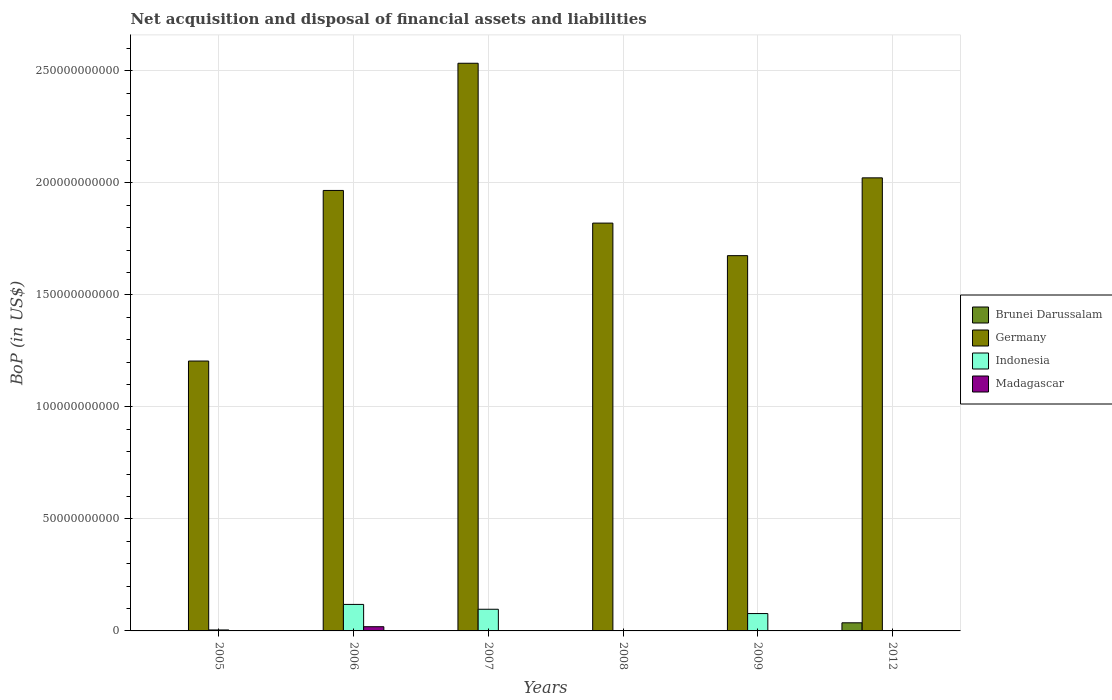How many different coloured bars are there?
Make the answer very short. 4. What is the Balance of Payments in Madagascar in 2008?
Ensure brevity in your answer.  0. Across all years, what is the maximum Balance of Payments in Indonesia?
Offer a terse response. 1.18e+1. Across all years, what is the minimum Balance of Payments in Germany?
Your answer should be very brief. 1.20e+11. What is the total Balance of Payments in Indonesia in the graph?
Provide a short and direct response. 2.99e+1. What is the difference between the Balance of Payments in Indonesia in 2006 and that in 2009?
Keep it short and to the point. 4.09e+09. What is the difference between the Balance of Payments in Brunei Darussalam in 2007 and the Balance of Payments in Germany in 2009?
Offer a terse response. -1.68e+11. What is the average Balance of Payments in Madagascar per year?
Make the answer very short. 3.13e+08. In the year 2012, what is the difference between the Balance of Payments in Brunei Darussalam and Balance of Payments in Germany?
Ensure brevity in your answer.  -1.99e+11. In how many years, is the Balance of Payments in Germany greater than 100000000000 US$?
Offer a very short reply. 6. What is the ratio of the Balance of Payments in Germany in 2006 to that in 2007?
Your response must be concise. 0.78. What is the difference between the highest and the second highest Balance of Payments in Indonesia?
Keep it short and to the point. 2.16e+09. What is the difference between the highest and the lowest Balance of Payments in Germany?
Give a very brief answer. 1.33e+11. In how many years, is the Balance of Payments in Madagascar greater than the average Balance of Payments in Madagascar taken over all years?
Provide a succinct answer. 1. Is the sum of the Balance of Payments in Germany in 2009 and 2012 greater than the maximum Balance of Payments in Indonesia across all years?
Give a very brief answer. Yes. Is it the case that in every year, the sum of the Balance of Payments in Brunei Darussalam and Balance of Payments in Germany is greater than the sum of Balance of Payments in Indonesia and Balance of Payments in Madagascar?
Your answer should be compact. No. Is it the case that in every year, the sum of the Balance of Payments in Madagascar and Balance of Payments in Brunei Darussalam is greater than the Balance of Payments in Indonesia?
Your answer should be very brief. No. How many years are there in the graph?
Make the answer very short. 6. Are the values on the major ticks of Y-axis written in scientific E-notation?
Your answer should be compact. No. Does the graph contain any zero values?
Provide a succinct answer. Yes. Where does the legend appear in the graph?
Offer a terse response. Center right. How many legend labels are there?
Keep it short and to the point. 4. How are the legend labels stacked?
Ensure brevity in your answer.  Vertical. What is the title of the graph?
Your response must be concise. Net acquisition and disposal of financial assets and liabilities. Does "Bosnia and Herzegovina" appear as one of the legend labels in the graph?
Keep it short and to the point. No. What is the label or title of the X-axis?
Provide a short and direct response. Years. What is the label or title of the Y-axis?
Your answer should be compact. BoP (in US$). What is the BoP (in US$) of Brunei Darussalam in 2005?
Your answer should be compact. 5.58e+07. What is the BoP (in US$) of Germany in 2005?
Your answer should be very brief. 1.20e+11. What is the BoP (in US$) of Indonesia in 2005?
Keep it short and to the point. 4.33e+08. What is the BoP (in US$) in Germany in 2006?
Provide a short and direct response. 1.97e+11. What is the BoP (in US$) in Indonesia in 2006?
Give a very brief answer. 1.18e+1. What is the BoP (in US$) of Madagascar in 2006?
Your answer should be very brief. 1.88e+09. What is the BoP (in US$) in Germany in 2007?
Your answer should be very brief. 2.53e+11. What is the BoP (in US$) in Indonesia in 2007?
Your answer should be very brief. 9.67e+09. What is the BoP (in US$) of Brunei Darussalam in 2008?
Provide a short and direct response. 0. What is the BoP (in US$) of Germany in 2008?
Your answer should be very brief. 1.82e+11. What is the BoP (in US$) of Indonesia in 2008?
Offer a terse response. 1.82e+08. What is the BoP (in US$) in Madagascar in 2008?
Offer a very short reply. 0. What is the BoP (in US$) in Germany in 2009?
Keep it short and to the point. 1.68e+11. What is the BoP (in US$) in Indonesia in 2009?
Offer a very short reply. 7.75e+09. What is the BoP (in US$) of Brunei Darussalam in 2012?
Keep it short and to the point. 3.62e+09. What is the BoP (in US$) of Germany in 2012?
Make the answer very short. 2.02e+11. What is the BoP (in US$) of Indonesia in 2012?
Your answer should be very brief. 0. What is the BoP (in US$) of Madagascar in 2012?
Give a very brief answer. 0. Across all years, what is the maximum BoP (in US$) of Brunei Darussalam?
Ensure brevity in your answer.  3.62e+09. Across all years, what is the maximum BoP (in US$) of Germany?
Give a very brief answer. 2.53e+11. Across all years, what is the maximum BoP (in US$) in Indonesia?
Provide a succinct answer. 1.18e+1. Across all years, what is the maximum BoP (in US$) of Madagascar?
Ensure brevity in your answer.  1.88e+09. Across all years, what is the minimum BoP (in US$) of Germany?
Your answer should be compact. 1.20e+11. What is the total BoP (in US$) in Brunei Darussalam in the graph?
Provide a succinct answer. 3.68e+09. What is the total BoP (in US$) of Germany in the graph?
Offer a terse response. 1.12e+12. What is the total BoP (in US$) in Indonesia in the graph?
Your response must be concise. 2.99e+1. What is the total BoP (in US$) of Madagascar in the graph?
Make the answer very short. 1.88e+09. What is the difference between the BoP (in US$) in Germany in 2005 and that in 2006?
Your answer should be very brief. -7.62e+1. What is the difference between the BoP (in US$) of Indonesia in 2005 and that in 2006?
Ensure brevity in your answer.  -1.14e+1. What is the difference between the BoP (in US$) in Germany in 2005 and that in 2007?
Give a very brief answer. -1.33e+11. What is the difference between the BoP (in US$) in Indonesia in 2005 and that in 2007?
Offer a very short reply. -9.24e+09. What is the difference between the BoP (in US$) of Germany in 2005 and that in 2008?
Give a very brief answer. -6.16e+1. What is the difference between the BoP (in US$) in Indonesia in 2005 and that in 2008?
Your answer should be compact. 2.51e+08. What is the difference between the BoP (in US$) of Germany in 2005 and that in 2009?
Your answer should be very brief. -4.70e+1. What is the difference between the BoP (in US$) of Indonesia in 2005 and that in 2009?
Your answer should be very brief. -7.32e+09. What is the difference between the BoP (in US$) in Brunei Darussalam in 2005 and that in 2012?
Your answer should be very brief. -3.57e+09. What is the difference between the BoP (in US$) in Germany in 2005 and that in 2012?
Ensure brevity in your answer.  -8.18e+1. What is the difference between the BoP (in US$) in Germany in 2006 and that in 2007?
Offer a very short reply. -5.68e+1. What is the difference between the BoP (in US$) in Indonesia in 2006 and that in 2007?
Make the answer very short. 2.16e+09. What is the difference between the BoP (in US$) in Germany in 2006 and that in 2008?
Provide a succinct answer. 1.46e+1. What is the difference between the BoP (in US$) of Indonesia in 2006 and that in 2008?
Provide a succinct answer. 1.17e+1. What is the difference between the BoP (in US$) of Germany in 2006 and that in 2009?
Keep it short and to the point. 2.91e+1. What is the difference between the BoP (in US$) in Indonesia in 2006 and that in 2009?
Keep it short and to the point. 4.09e+09. What is the difference between the BoP (in US$) of Germany in 2006 and that in 2012?
Provide a succinct answer. -5.62e+09. What is the difference between the BoP (in US$) of Germany in 2007 and that in 2008?
Ensure brevity in your answer.  7.13e+1. What is the difference between the BoP (in US$) of Indonesia in 2007 and that in 2008?
Provide a succinct answer. 9.49e+09. What is the difference between the BoP (in US$) of Germany in 2007 and that in 2009?
Ensure brevity in your answer.  8.59e+1. What is the difference between the BoP (in US$) of Indonesia in 2007 and that in 2009?
Your answer should be compact. 1.92e+09. What is the difference between the BoP (in US$) of Germany in 2007 and that in 2012?
Your answer should be compact. 5.11e+1. What is the difference between the BoP (in US$) in Germany in 2008 and that in 2009?
Ensure brevity in your answer.  1.45e+1. What is the difference between the BoP (in US$) in Indonesia in 2008 and that in 2009?
Ensure brevity in your answer.  -7.57e+09. What is the difference between the BoP (in US$) in Germany in 2008 and that in 2012?
Ensure brevity in your answer.  -2.02e+1. What is the difference between the BoP (in US$) in Germany in 2009 and that in 2012?
Keep it short and to the point. -3.47e+1. What is the difference between the BoP (in US$) in Brunei Darussalam in 2005 and the BoP (in US$) in Germany in 2006?
Give a very brief answer. -1.97e+11. What is the difference between the BoP (in US$) in Brunei Darussalam in 2005 and the BoP (in US$) in Indonesia in 2006?
Give a very brief answer. -1.18e+1. What is the difference between the BoP (in US$) in Brunei Darussalam in 2005 and the BoP (in US$) in Madagascar in 2006?
Your answer should be very brief. -1.82e+09. What is the difference between the BoP (in US$) of Germany in 2005 and the BoP (in US$) of Indonesia in 2006?
Provide a short and direct response. 1.09e+11. What is the difference between the BoP (in US$) in Germany in 2005 and the BoP (in US$) in Madagascar in 2006?
Offer a terse response. 1.19e+11. What is the difference between the BoP (in US$) of Indonesia in 2005 and the BoP (in US$) of Madagascar in 2006?
Your answer should be compact. -1.45e+09. What is the difference between the BoP (in US$) in Brunei Darussalam in 2005 and the BoP (in US$) in Germany in 2007?
Make the answer very short. -2.53e+11. What is the difference between the BoP (in US$) of Brunei Darussalam in 2005 and the BoP (in US$) of Indonesia in 2007?
Your response must be concise. -9.61e+09. What is the difference between the BoP (in US$) of Germany in 2005 and the BoP (in US$) of Indonesia in 2007?
Provide a short and direct response. 1.11e+11. What is the difference between the BoP (in US$) in Brunei Darussalam in 2005 and the BoP (in US$) in Germany in 2008?
Provide a short and direct response. -1.82e+11. What is the difference between the BoP (in US$) in Brunei Darussalam in 2005 and the BoP (in US$) in Indonesia in 2008?
Provide a succinct answer. -1.26e+08. What is the difference between the BoP (in US$) of Germany in 2005 and the BoP (in US$) of Indonesia in 2008?
Offer a terse response. 1.20e+11. What is the difference between the BoP (in US$) in Brunei Darussalam in 2005 and the BoP (in US$) in Germany in 2009?
Offer a terse response. -1.67e+11. What is the difference between the BoP (in US$) in Brunei Darussalam in 2005 and the BoP (in US$) in Indonesia in 2009?
Offer a very short reply. -7.69e+09. What is the difference between the BoP (in US$) of Germany in 2005 and the BoP (in US$) of Indonesia in 2009?
Offer a very short reply. 1.13e+11. What is the difference between the BoP (in US$) in Brunei Darussalam in 2005 and the BoP (in US$) in Germany in 2012?
Offer a terse response. -2.02e+11. What is the difference between the BoP (in US$) of Germany in 2006 and the BoP (in US$) of Indonesia in 2007?
Provide a short and direct response. 1.87e+11. What is the difference between the BoP (in US$) of Germany in 2006 and the BoP (in US$) of Indonesia in 2008?
Offer a very short reply. 1.96e+11. What is the difference between the BoP (in US$) in Germany in 2006 and the BoP (in US$) in Indonesia in 2009?
Your response must be concise. 1.89e+11. What is the difference between the BoP (in US$) in Germany in 2007 and the BoP (in US$) in Indonesia in 2008?
Your answer should be very brief. 2.53e+11. What is the difference between the BoP (in US$) in Germany in 2007 and the BoP (in US$) in Indonesia in 2009?
Your answer should be very brief. 2.46e+11. What is the difference between the BoP (in US$) in Germany in 2008 and the BoP (in US$) in Indonesia in 2009?
Provide a succinct answer. 1.74e+11. What is the average BoP (in US$) of Brunei Darussalam per year?
Offer a very short reply. 6.13e+08. What is the average BoP (in US$) in Germany per year?
Offer a very short reply. 1.87e+11. What is the average BoP (in US$) of Indonesia per year?
Offer a very short reply. 4.98e+09. What is the average BoP (in US$) in Madagascar per year?
Provide a short and direct response. 3.13e+08. In the year 2005, what is the difference between the BoP (in US$) of Brunei Darussalam and BoP (in US$) of Germany?
Your answer should be compact. -1.20e+11. In the year 2005, what is the difference between the BoP (in US$) in Brunei Darussalam and BoP (in US$) in Indonesia?
Your response must be concise. -3.77e+08. In the year 2005, what is the difference between the BoP (in US$) in Germany and BoP (in US$) in Indonesia?
Ensure brevity in your answer.  1.20e+11. In the year 2006, what is the difference between the BoP (in US$) in Germany and BoP (in US$) in Indonesia?
Your answer should be compact. 1.85e+11. In the year 2006, what is the difference between the BoP (in US$) in Germany and BoP (in US$) in Madagascar?
Your answer should be compact. 1.95e+11. In the year 2006, what is the difference between the BoP (in US$) in Indonesia and BoP (in US$) in Madagascar?
Keep it short and to the point. 9.96e+09. In the year 2007, what is the difference between the BoP (in US$) of Germany and BoP (in US$) of Indonesia?
Keep it short and to the point. 2.44e+11. In the year 2008, what is the difference between the BoP (in US$) of Germany and BoP (in US$) of Indonesia?
Ensure brevity in your answer.  1.82e+11. In the year 2009, what is the difference between the BoP (in US$) of Germany and BoP (in US$) of Indonesia?
Provide a succinct answer. 1.60e+11. In the year 2012, what is the difference between the BoP (in US$) in Brunei Darussalam and BoP (in US$) in Germany?
Offer a terse response. -1.99e+11. What is the ratio of the BoP (in US$) of Germany in 2005 to that in 2006?
Offer a very short reply. 0.61. What is the ratio of the BoP (in US$) in Indonesia in 2005 to that in 2006?
Offer a terse response. 0.04. What is the ratio of the BoP (in US$) in Germany in 2005 to that in 2007?
Offer a very short reply. 0.48. What is the ratio of the BoP (in US$) in Indonesia in 2005 to that in 2007?
Offer a very short reply. 0.04. What is the ratio of the BoP (in US$) in Germany in 2005 to that in 2008?
Give a very brief answer. 0.66. What is the ratio of the BoP (in US$) of Indonesia in 2005 to that in 2008?
Offer a terse response. 2.38. What is the ratio of the BoP (in US$) in Germany in 2005 to that in 2009?
Your response must be concise. 0.72. What is the ratio of the BoP (in US$) of Indonesia in 2005 to that in 2009?
Offer a very short reply. 0.06. What is the ratio of the BoP (in US$) of Brunei Darussalam in 2005 to that in 2012?
Your answer should be compact. 0.02. What is the ratio of the BoP (in US$) in Germany in 2005 to that in 2012?
Your answer should be very brief. 0.6. What is the ratio of the BoP (in US$) in Germany in 2006 to that in 2007?
Make the answer very short. 0.78. What is the ratio of the BoP (in US$) of Indonesia in 2006 to that in 2007?
Make the answer very short. 1.22. What is the ratio of the BoP (in US$) of Germany in 2006 to that in 2008?
Provide a succinct answer. 1.08. What is the ratio of the BoP (in US$) of Indonesia in 2006 to that in 2008?
Your answer should be very brief. 65.13. What is the ratio of the BoP (in US$) of Germany in 2006 to that in 2009?
Provide a short and direct response. 1.17. What is the ratio of the BoP (in US$) of Indonesia in 2006 to that in 2009?
Provide a short and direct response. 1.53. What is the ratio of the BoP (in US$) of Germany in 2006 to that in 2012?
Your answer should be very brief. 0.97. What is the ratio of the BoP (in US$) in Germany in 2007 to that in 2008?
Your response must be concise. 1.39. What is the ratio of the BoP (in US$) of Indonesia in 2007 to that in 2008?
Ensure brevity in your answer.  53.22. What is the ratio of the BoP (in US$) in Germany in 2007 to that in 2009?
Your answer should be very brief. 1.51. What is the ratio of the BoP (in US$) in Indonesia in 2007 to that in 2009?
Keep it short and to the point. 1.25. What is the ratio of the BoP (in US$) of Germany in 2007 to that in 2012?
Offer a very short reply. 1.25. What is the ratio of the BoP (in US$) in Germany in 2008 to that in 2009?
Make the answer very short. 1.09. What is the ratio of the BoP (in US$) in Indonesia in 2008 to that in 2009?
Ensure brevity in your answer.  0.02. What is the ratio of the BoP (in US$) of Germany in 2008 to that in 2012?
Make the answer very short. 0.9. What is the ratio of the BoP (in US$) in Germany in 2009 to that in 2012?
Provide a succinct answer. 0.83. What is the difference between the highest and the second highest BoP (in US$) of Germany?
Make the answer very short. 5.11e+1. What is the difference between the highest and the second highest BoP (in US$) in Indonesia?
Keep it short and to the point. 2.16e+09. What is the difference between the highest and the lowest BoP (in US$) in Brunei Darussalam?
Ensure brevity in your answer.  3.62e+09. What is the difference between the highest and the lowest BoP (in US$) in Germany?
Your answer should be compact. 1.33e+11. What is the difference between the highest and the lowest BoP (in US$) in Indonesia?
Make the answer very short. 1.18e+1. What is the difference between the highest and the lowest BoP (in US$) of Madagascar?
Provide a succinct answer. 1.88e+09. 